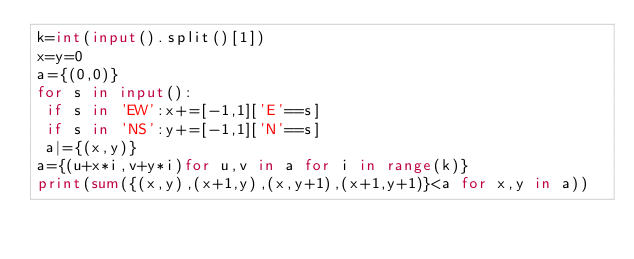Convert code to text. <code><loc_0><loc_0><loc_500><loc_500><_Python_>k=int(input().split()[1])
x=y=0
a={(0,0)}
for s in input():
 if s in 'EW':x+=[-1,1]['E'==s]
 if s in 'NS':y+=[-1,1]['N'==s]
 a|={(x,y)}
a={(u+x*i,v+y*i)for u,v in a for i in range(k)}
print(sum({(x,y),(x+1,y),(x,y+1),(x+1,y+1)}<a for x,y in a))
</code> 